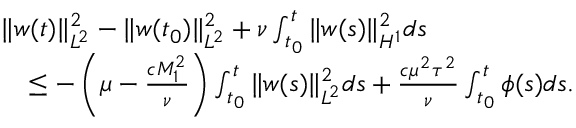<formula> <loc_0><loc_0><loc_500><loc_500>\begin{array} { r l } & { \| w ( t ) \| _ { L ^ { 2 } } ^ { 2 } - \| w ( t _ { 0 } ) \| _ { L ^ { 2 } } ^ { 2 } + \nu \int _ { t _ { 0 } } ^ { t } \| w ( s ) \| _ { H ^ { 1 } } ^ { 2 } d s } \\ & { \quad \leq - \left ( \mu - \frac { c M _ { 1 } ^ { 2 } } { \nu } \right ) \int _ { t _ { 0 } } ^ { t } \| w ( s ) \| _ { L ^ { 2 } } ^ { 2 } d s + \frac { c \mu ^ { 2 } \tau ^ { 2 } } { \nu } \int _ { t _ { 0 } } ^ { t } \phi ( s ) d s . } \end{array}</formula> 